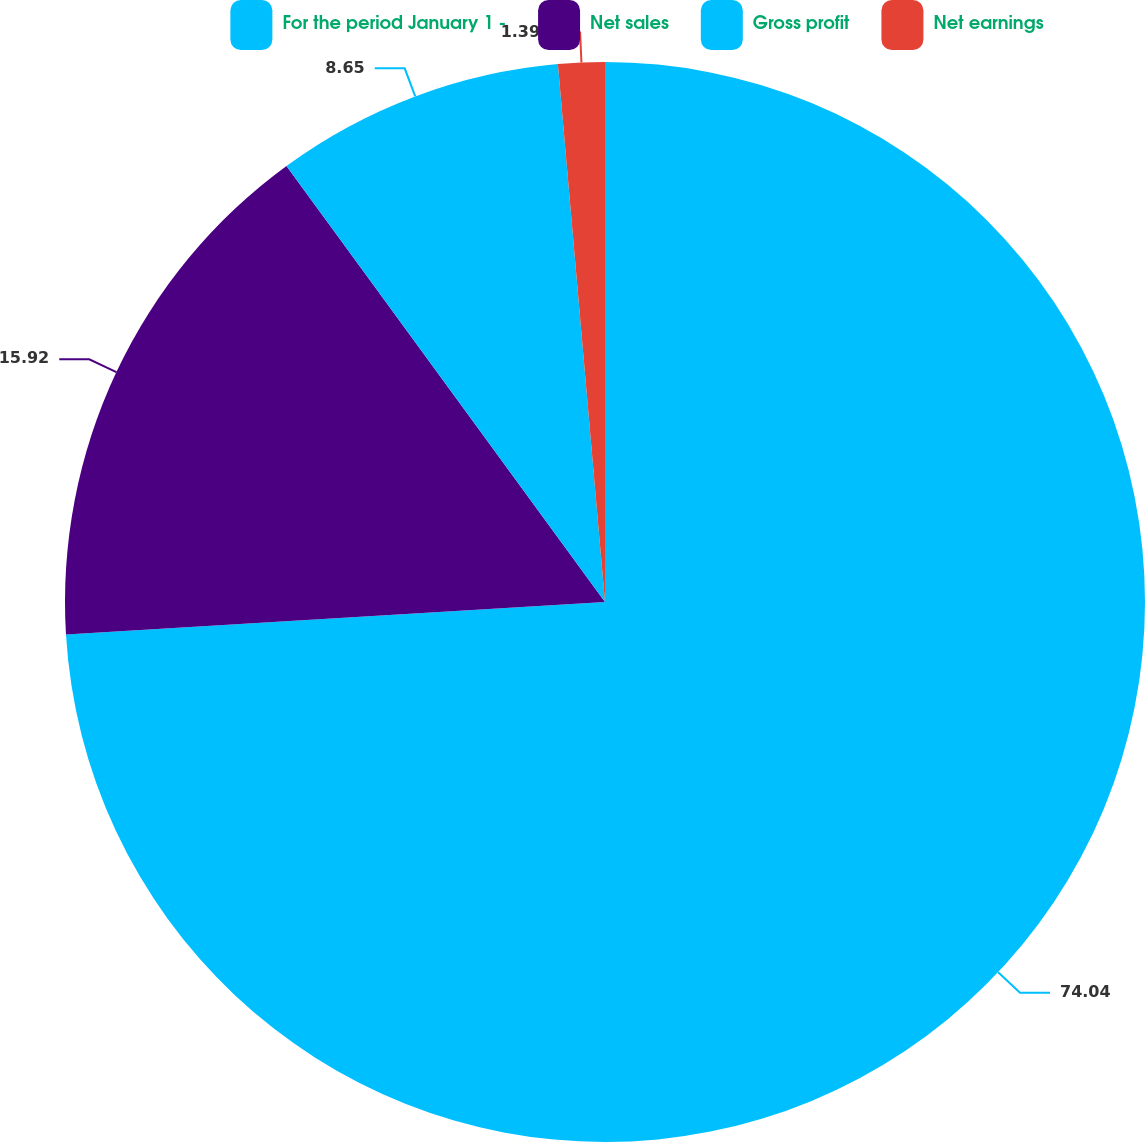Convert chart to OTSL. <chart><loc_0><loc_0><loc_500><loc_500><pie_chart><fcel>For the period January 1 -<fcel>Net sales<fcel>Gross profit<fcel>Net earnings<nl><fcel>74.04%<fcel>15.92%<fcel>8.65%<fcel>1.39%<nl></chart> 